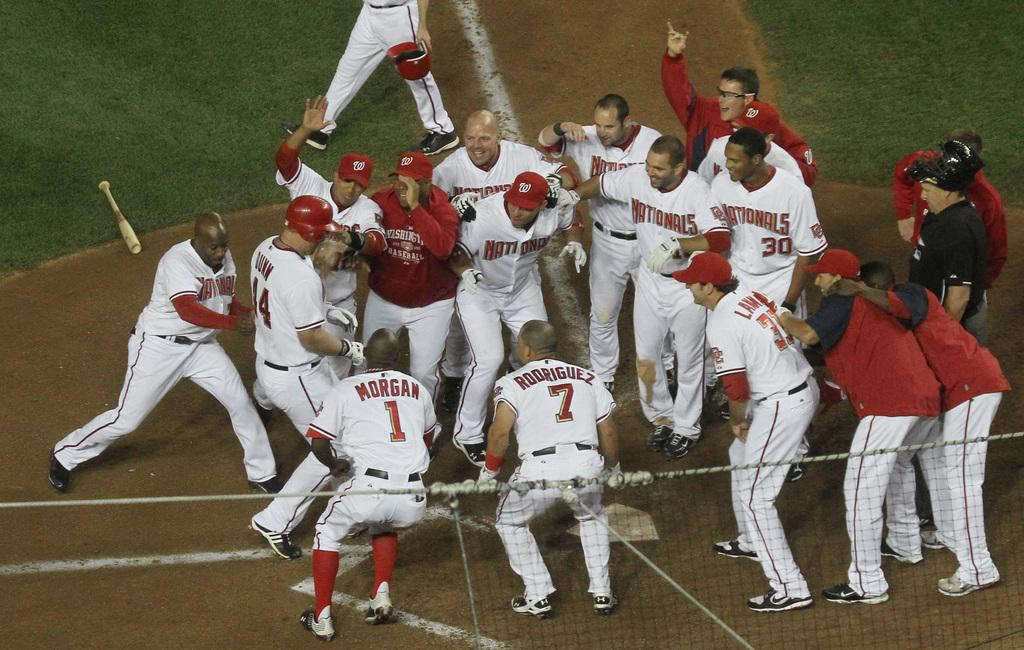<image>
Describe the image concisely. Player number 7 is near the outside of a cluster of players. 